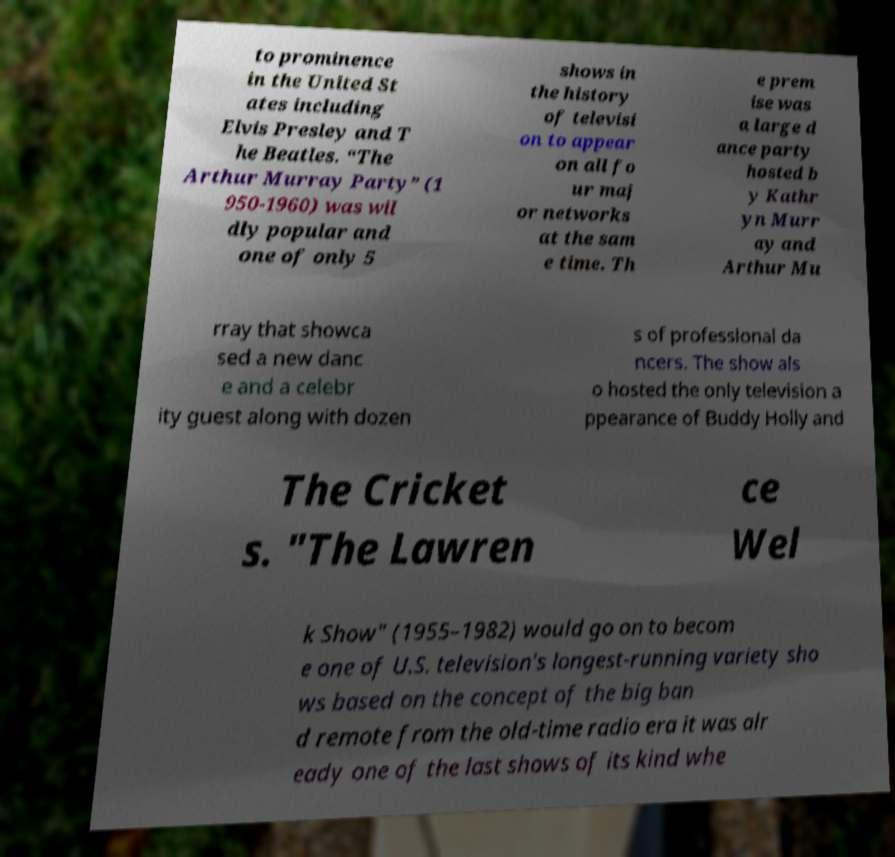There's text embedded in this image that I need extracted. Can you transcribe it verbatim? to prominence in the United St ates including Elvis Presley and T he Beatles. “The Arthur Murray Party” (1 950-1960) was wil dly popular and one of only 5 shows in the history of televisi on to appear on all fo ur maj or networks at the sam e time. Th e prem ise was a large d ance party hosted b y Kathr yn Murr ay and Arthur Mu rray that showca sed a new danc e and a celebr ity guest along with dozen s of professional da ncers. The show als o hosted the only television a ppearance of Buddy Holly and The Cricket s. "The Lawren ce Wel k Show" (1955–1982) would go on to becom e one of U.S. television's longest-running variety sho ws based on the concept of the big ban d remote from the old-time radio era it was alr eady one of the last shows of its kind whe 